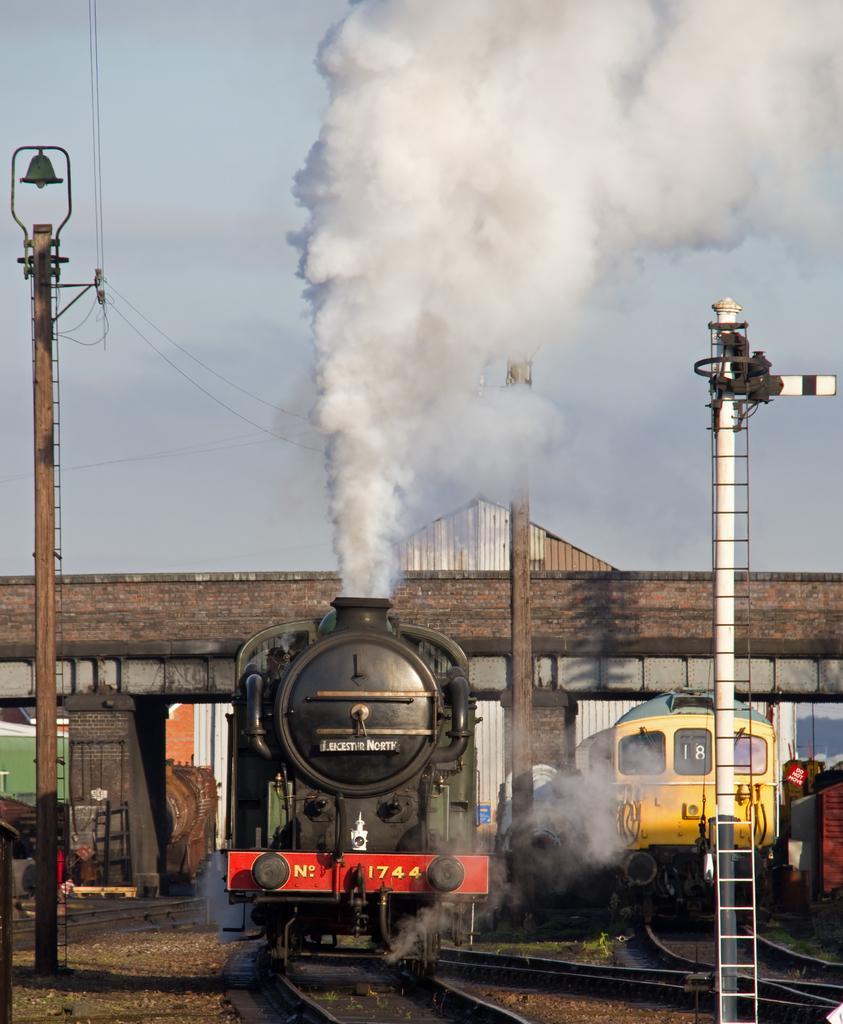Describe this image in one or two sentences. In this image I can see there are two trains visible on railway track and there is a pole visible on the right side , in the middle there is a bridge , pole, smoke , on the left side there is another pole , power line cables,at the top there is the sky. 